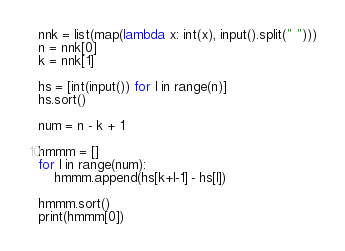Convert code to text. <code><loc_0><loc_0><loc_500><loc_500><_Python_>nnk = list(map(lambda x: int(x), input().split(" ")))
n = nnk[0]
k = nnk[1]

hs = [int(input()) for l in range(n)]
hs.sort()

num = n - k + 1

hmmm = []
for l in range(num):
    hmmm.append(hs[k+l-1] - hs[l])

hmmm.sort()
print(hmmm[0])</code> 